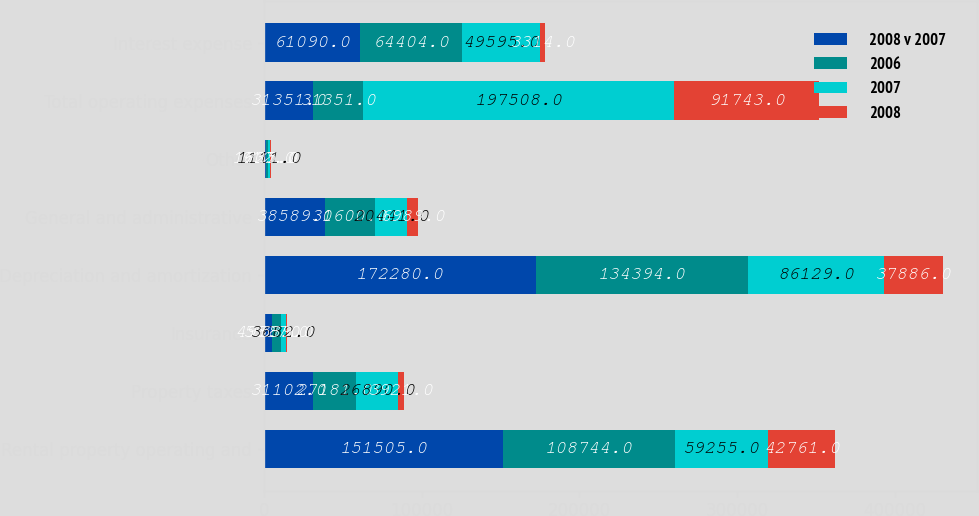Convert chart. <chart><loc_0><loc_0><loc_500><loc_500><stacked_bar_chart><ecel><fcel>Rental property operating and<fcel>Property taxes<fcel>Insurance<fcel>Depreciation and amortization<fcel>General and administrative<fcel>Other<fcel>Total operating expenses<fcel>Interest expense<nl><fcel>2008 v 2007<fcel>151505<fcel>31102<fcel>4988<fcel>172280<fcel>38589<fcel>1637<fcel>31351<fcel>61090<nl><fcel>2006<fcel>108744<fcel>27181<fcel>5527<fcel>134394<fcel>31600<fcel>912<fcel>31351<fcel>64404<nl><fcel>2007<fcel>59255<fcel>26890<fcel>3682<fcel>86129<fcel>20441<fcel>1111<fcel>197508<fcel>49595<nl><fcel>2008<fcel>42761<fcel>3921<fcel>539<fcel>37886<fcel>6989<fcel>725<fcel>91743<fcel>3314<nl></chart> 